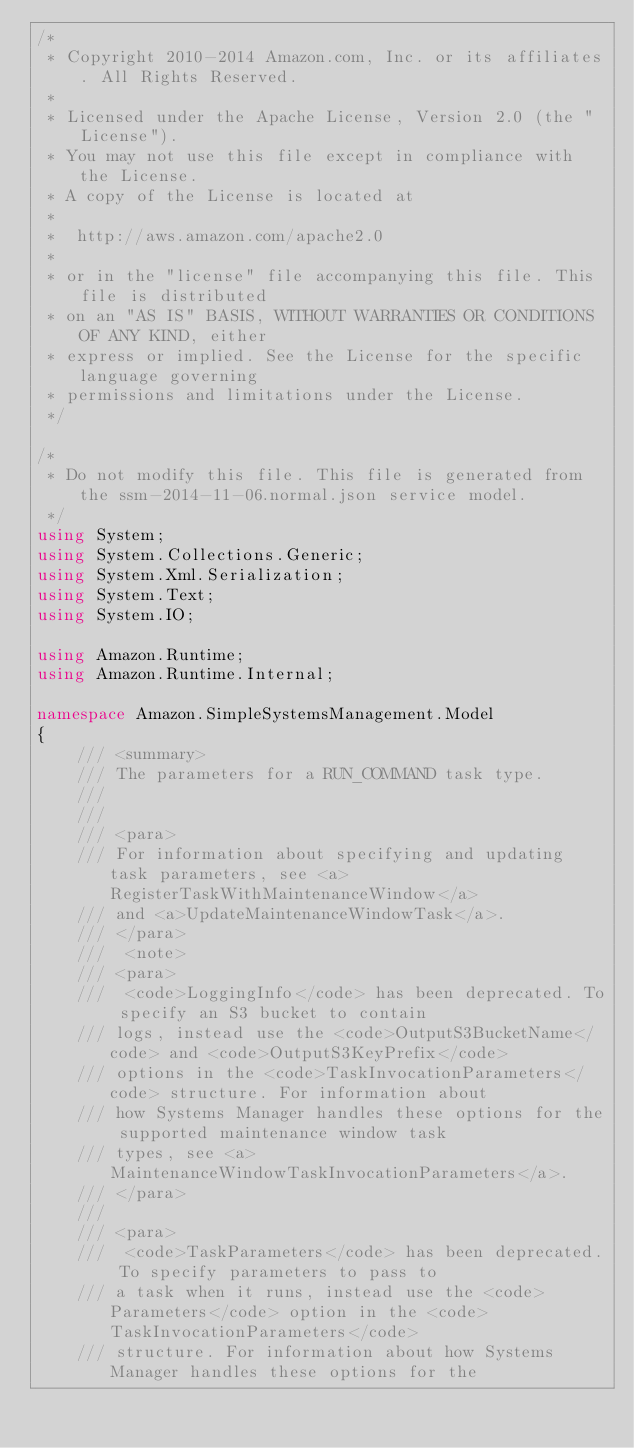Convert code to text. <code><loc_0><loc_0><loc_500><loc_500><_C#_>/*
 * Copyright 2010-2014 Amazon.com, Inc. or its affiliates. All Rights Reserved.
 * 
 * Licensed under the Apache License, Version 2.0 (the "License").
 * You may not use this file except in compliance with the License.
 * A copy of the License is located at
 * 
 *  http://aws.amazon.com/apache2.0
 * 
 * or in the "license" file accompanying this file. This file is distributed
 * on an "AS IS" BASIS, WITHOUT WARRANTIES OR CONDITIONS OF ANY KIND, either
 * express or implied. See the License for the specific language governing
 * permissions and limitations under the License.
 */

/*
 * Do not modify this file. This file is generated from the ssm-2014-11-06.normal.json service model.
 */
using System;
using System.Collections.Generic;
using System.Xml.Serialization;
using System.Text;
using System.IO;

using Amazon.Runtime;
using Amazon.Runtime.Internal;

namespace Amazon.SimpleSystemsManagement.Model
{
    /// <summary>
    /// The parameters for a RUN_COMMAND task type.
    /// 
    ///  
    /// <para>
    /// For information about specifying and updating task parameters, see <a>RegisterTaskWithMaintenanceWindow</a>
    /// and <a>UpdateMaintenanceWindowTask</a>.
    /// </para>
    ///  <note> 
    /// <para>
    ///  <code>LoggingInfo</code> has been deprecated. To specify an S3 bucket to contain
    /// logs, instead use the <code>OutputS3BucketName</code> and <code>OutputS3KeyPrefix</code>
    /// options in the <code>TaskInvocationParameters</code> structure. For information about
    /// how Systems Manager handles these options for the supported maintenance window task
    /// types, see <a>MaintenanceWindowTaskInvocationParameters</a>.
    /// </para>
    ///  
    /// <para>
    ///  <code>TaskParameters</code> has been deprecated. To specify parameters to pass to
    /// a task when it runs, instead use the <code>Parameters</code> option in the <code>TaskInvocationParameters</code>
    /// structure. For information about how Systems Manager handles these options for the</code> 